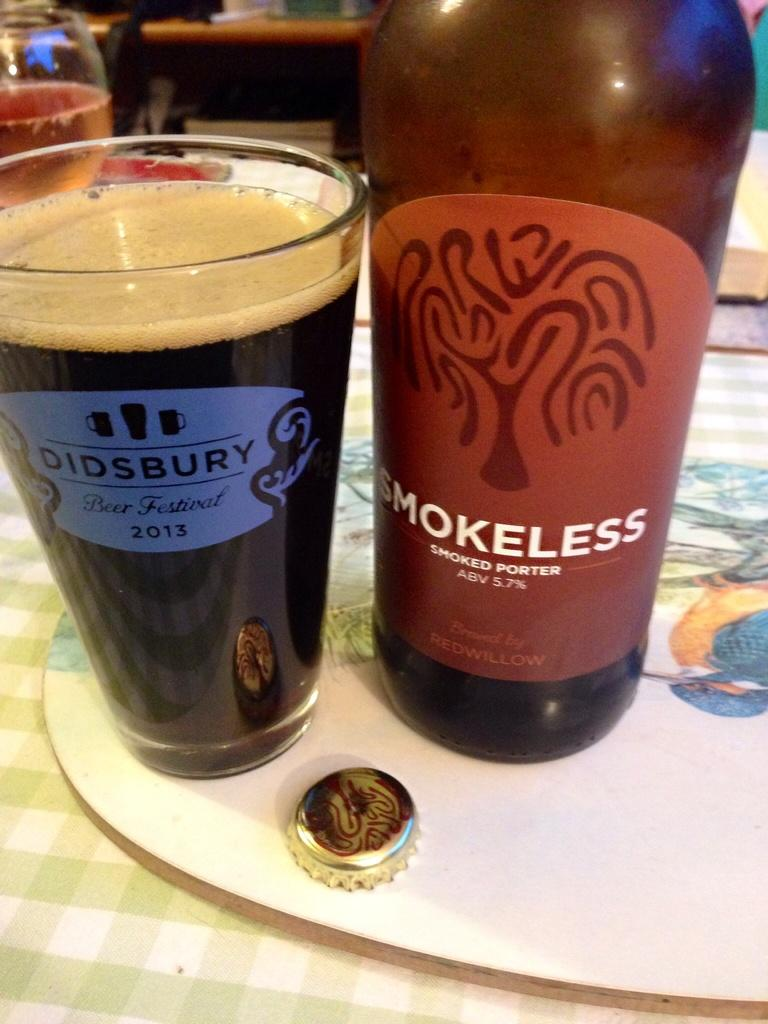<image>
Create a compact narrative representing the image presented. A smoked porter wine bottle is next to a glass with the year 2013 on it. 